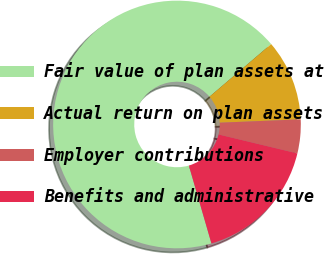<chart> <loc_0><loc_0><loc_500><loc_500><pie_chart><fcel>Fair value of plan assets at<fcel>Actual return on plan assets<fcel>Employer contributions<fcel>Benefits and administrative<nl><fcel>68.24%<fcel>10.59%<fcel>4.41%<fcel>16.76%<nl></chart> 